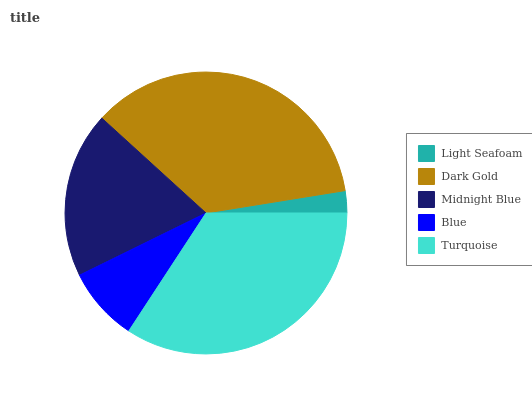Is Light Seafoam the minimum?
Answer yes or no. Yes. Is Dark Gold the maximum?
Answer yes or no. Yes. Is Midnight Blue the minimum?
Answer yes or no. No. Is Midnight Blue the maximum?
Answer yes or no. No. Is Dark Gold greater than Midnight Blue?
Answer yes or no. Yes. Is Midnight Blue less than Dark Gold?
Answer yes or no. Yes. Is Midnight Blue greater than Dark Gold?
Answer yes or no. No. Is Dark Gold less than Midnight Blue?
Answer yes or no. No. Is Midnight Blue the high median?
Answer yes or no. Yes. Is Midnight Blue the low median?
Answer yes or no. Yes. Is Turquoise the high median?
Answer yes or no. No. Is Turquoise the low median?
Answer yes or no. No. 